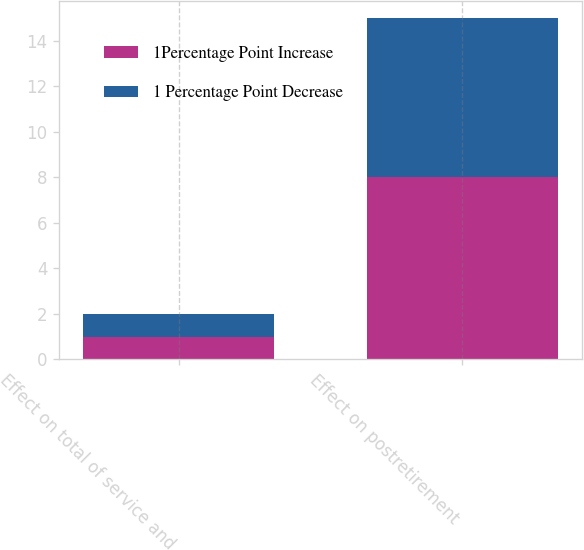Convert chart to OTSL. <chart><loc_0><loc_0><loc_500><loc_500><stacked_bar_chart><ecel><fcel>Effect on total of service and<fcel>Effect on postretirement<nl><fcel>1Percentage Point Increase<fcel>1<fcel>8<nl><fcel>1 Percentage Point Decrease<fcel>1<fcel>7<nl></chart> 